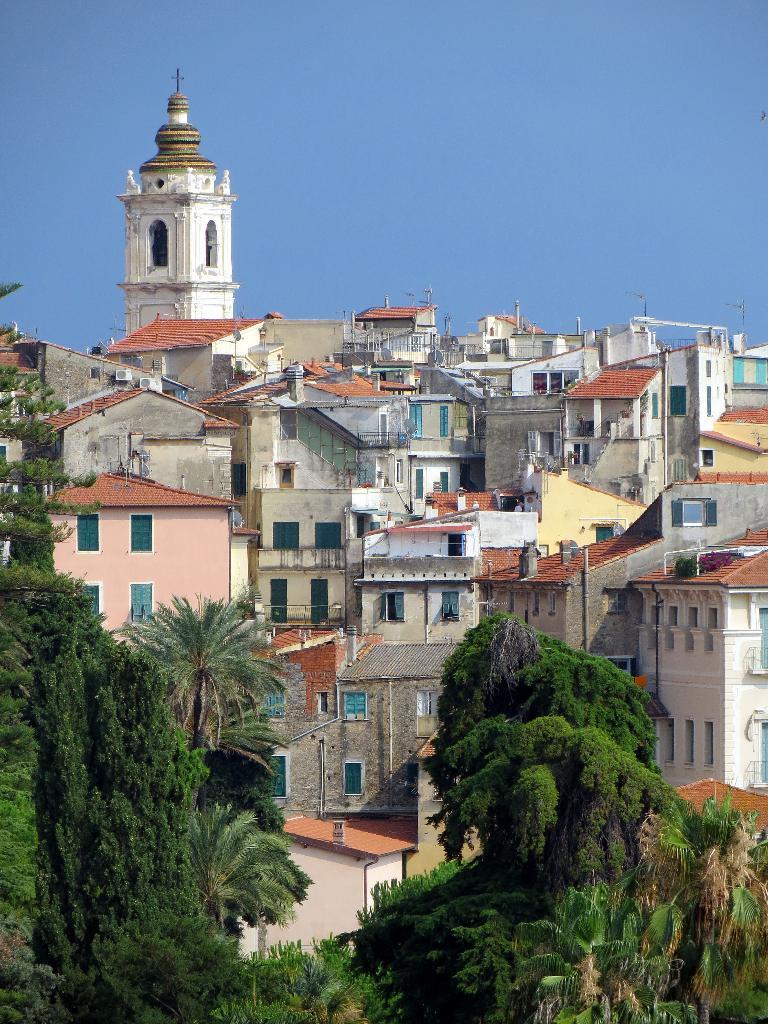In one or two sentences, can you explain what this image depicts? This is an outside view. At the bottom there are many trees. In the background there are many buildings. At the top of the image I can see the sky. 